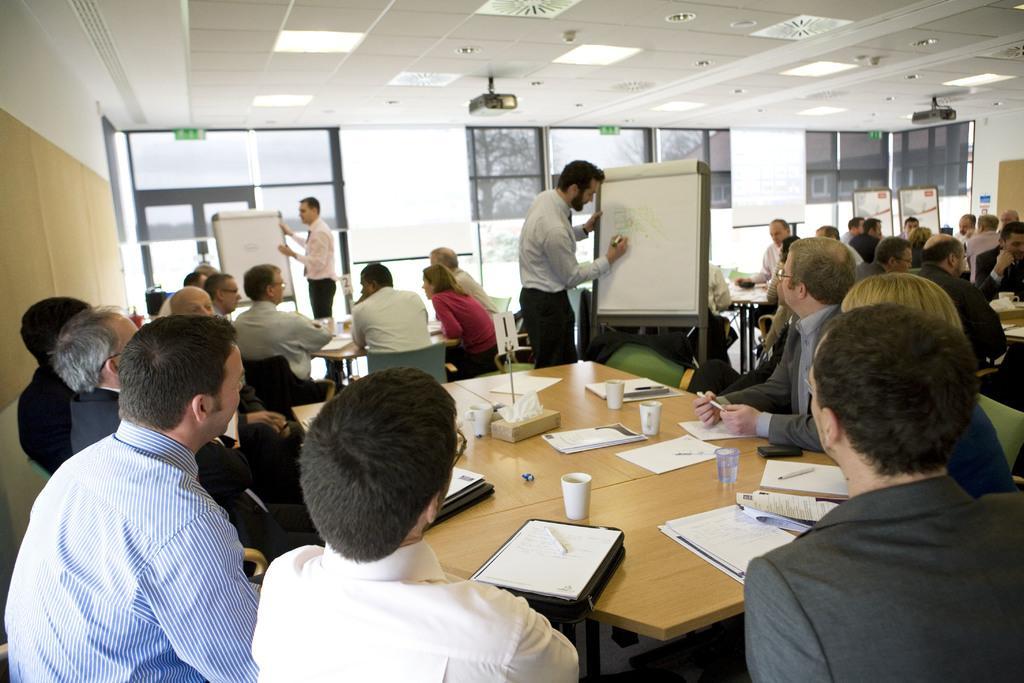Can you describe this image briefly? In this picture we can see some persons are sitting on the chairs around the table. And here we can see two persons standing and explaining something on the board. On the table there are paper, cups, and files. And in the background there is a wall. And these are the lights. 